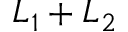Convert formula to latex. <formula><loc_0><loc_0><loc_500><loc_500>L _ { 1 } + L _ { 2 }</formula> 